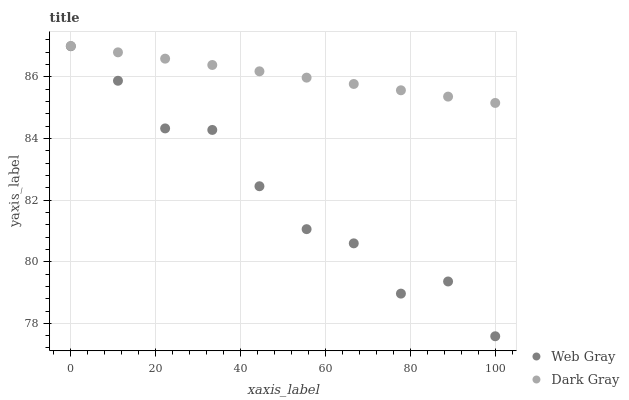Does Web Gray have the minimum area under the curve?
Answer yes or no. Yes. Does Dark Gray have the maximum area under the curve?
Answer yes or no. Yes. Does Web Gray have the maximum area under the curve?
Answer yes or no. No. Is Dark Gray the smoothest?
Answer yes or no. Yes. Is Web Gray the roughest?
Answer yes or no. Yes. Is Web Gray the smoothest?
Answer yes or no. No. Does Web Gray have the lowest value?
Answer yes or no. Yes. Does Dark Gray have the highest value?
Answer yes or no. Yes. Does Web Gray have the highest value?
Answer yes or no. No. Is Web Gray less than Dark Gray?
Answer yes or no. Yes. Is Dark Gray greater than Web Gray?
Answer yes or no. Yes. Does Web Gray intersect Dark Gray?
Answer yes or no. No. 